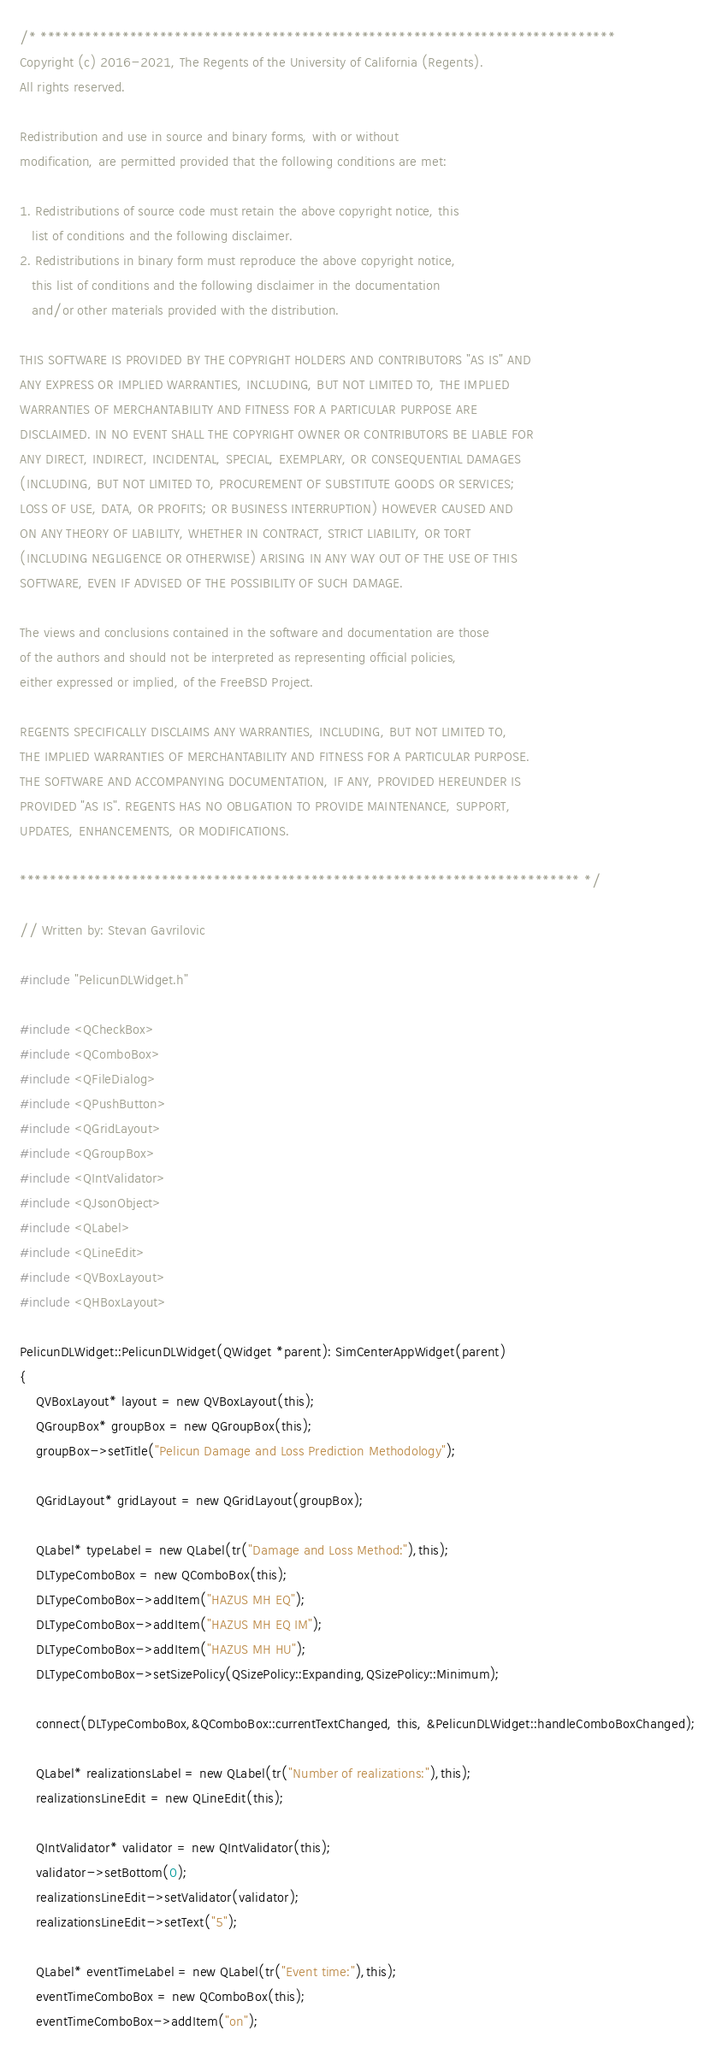Convert code to text. <code><loc_0><loc_0><loc_500><loc_500><_C++_>/* *****************************************************************************
Copyright (c) 2016-2021, The Regents of the University of California (Regents).
All rights reserved.

Redistribution and use in source and binary forms, with or without
modification, are permitted provided that the following conditions are met:

1. Redistributions of source code must retain the above copyright notice, this
   list of conditions and the following disclaimer.
2. Redistributions in binary form must reproduce the above copyright notice,
   this list of conditions and the following disclaimer in the documentation
   and/or other materials provided with the distribution.

THIS SOFTWARE IS PROVIDED BY THE COPYRIGHT HOLDERS AND CONTRIBUTORS "AS IS" AND
ANY EXPRESS OR IMPLIED WARRANTIES, INCLUDING, BUT NOT LIMITED TO, THE IMPLIED
WARRANTIES OF MERCHANTABILITY AND FITNESS FOR A PARTICULAR PURPOSE ARE
DISCLAIMED. IN NO EVENT SHALL THE COPYRIGHT OWNER OR CONTRIBUTORS BE LIABLE FOR
ANY DIRECT, INDIRECT, INCIDENTAL, SPECIAL, EXEMPLARY, OR CONSEQUENTIAL DAMAGES
(INCLUDING, BUT NOT LIMITED TO, PROCUREMENT OF SUBSTITUTE GOODS OR SERVICES;
LOSS OF USE, DATA, OR PROFITS; OR BUSINESS INTERRUPTION) HOWEVER CAUSED AND
ON ANY THEORY OF LIABILITY, WHETHER IN CONTRACT, STRICT LIABILITY, OR TORT
(INCLUDING NEGLIGENCE OR OTHERWISE) ARISING IN ANY WAY OUT OF THE USE OF THIS
SOFTWARE, EVEN IF ADVISED OF THE POSSIBILITY OF SUCH DAMAGE.

The views and conclusions contained in the software and documentation are those
of the authors and should not be interpreted as representing official policies,
either expressed or implied, of the FreeBSD Project.

REGENTS SPECIFICALLY DISCLAIMS ANY WARRANTIES, INCLUDING, BUT NOT LIMITED TO,
THE IMPLIED WARRANTIES OF MERCHANTABILITY AND FITNESS FOR A PARTICULAR PURPOSE.
THE SOFTWARE AND ACCOMPANYING DOCUMENTATION, IF ANY, PROVIDED HEREUNDER IS
PROVIDED "AS IS". REGENTS HAS NO OBLIGATION TO PROVIDE MAINTENANCE, SUPPORT,
UPDATES, ENHANCEMENTS, OR MODIFICATIONS.

*************************************************************************** */

// Written by: Stevan Gavrilovic

#include "PelicunDLWidget.h"

#include <QCheckBox>
#include <QComboBox>
#include <QFileDialog>
#include <QPushButton>
#include <QGridLayout>
#include <QGroupBox>
#include <QIntValidator>
#include <QJsonObject>
#include <QLabel>
#include <QLineEdit>
#include <QVBoxLayout>
#include <QHBoxLayout>

PelicunDLWidget::PelicunDLWidget(QWidget *parent): SimCenterAppWidget(parent)
{
    QVBoxLayout* layout = new QVBoxLayout(this);
    QGroupBox* groupBox = new QGroupBox(this);
    groupBox->setTitle("Pelicun Damage and Loss Prediction Methodology");

    QGridLayout* gridLayout = new QGridLayout(groupBox);

    QLabel* typeLabel = new QLabel(tr("Damage and Loss Method:"),this);
    DLTypeComboBox = new QComboBox(this);
    DLTypeComboBox->addItem("HAZUS MH EQ");
    DLTypeComboBox->addItem("HAZUS MH EQ IM");
    DLTypeComboBox->addItem("HAZUS MH HU");
    DLTypeComboBox->setSizePolicy(QSizePolicy::Expanding,QSizePolicy::Minimum);

    connect(DLTypeComboBox,&QComboBox::currentTextChanged, this, &PelicunDLWidget::handleComboBoxChanged);

    QLabel* realizationsLabel = new QLabel(tr("Number of realizations:"),this);
    realizationsLineEdit = new QLineEdit(this);

    QIntValidator* validator = new QIntValidator(this);
    validator->setBottom(0);
    realizationsLineEdit->setValidator(validator);
    realizationsLineEdit->setText("5");

    QLabel* eventTimeLabel = new QLabel(tr("Event time:"),this);
    eventTimeComboBox = new QComboBox(this);
    eventTimeComboBox->addItem("on");</code> 